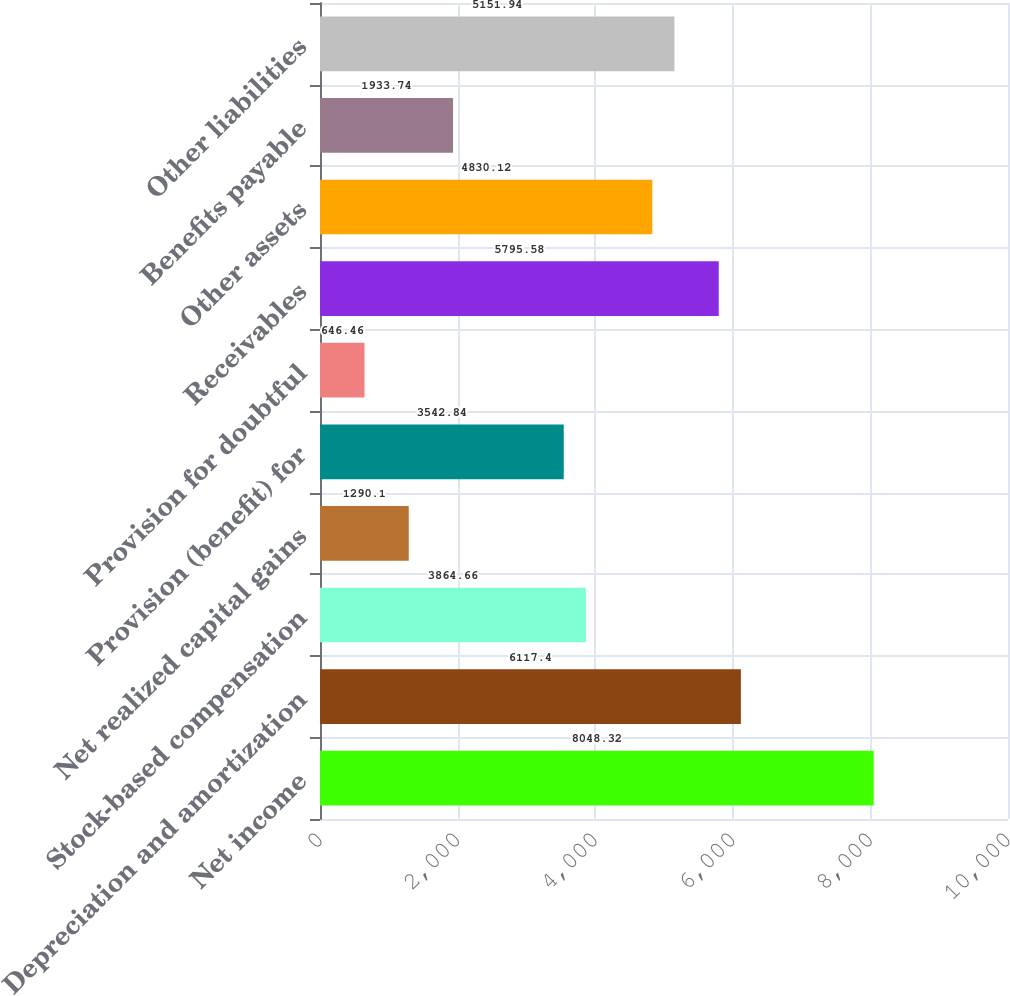Convert chart. <chart><loc_0><loc_0><loc_500><loc_500><bar_chart><fcel>Net income<fcel>Depreciation and amortization<fcel>Stock-based compensation<fcel>Net realized capital gains<fcel>Provision (benefit) for<fcel>Provision for doubtful<fcel>Receivables<fcel>Other assets<fcel>Benefits payable<fcel>Other liabilities<nl><fcel>8048.32<fcel>6117.4<fcel>3864.66<fcel>1290.1<fcel>3542.84<fcel>646.46<fcel>5795.58<fcel>4830.12<fcel>1933.74<fcel>5151.94<nl></chart> 